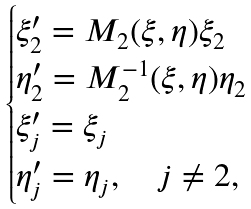<formula> <loc_0><loc_0><loc_500><loc_500>\begin{cases} \xi ^ { \prime } _ { 2 } = M _ { 2 } ( \xi , \eta ) \xi _ { 2 } \\ \eta ^ { \prime } _ { 2 } = M _ { 2 } ^ { - 1 } ( \xi , \eta ) \eta _ { 2 } \\ \xi ^ { \prime } _ { j } = \xi _ { j } \\ \eta ^ { \prime } _ { j } = \eta _ { j } , \quad j \neq 2 , \end{cases}</formula> 